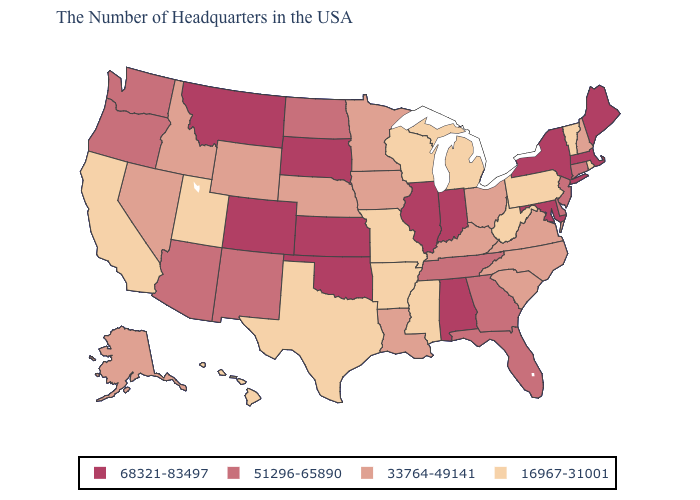Does the first symbol in the legend represent the smallest category?
Give a very brief answer. No. Which states have the highest value in the USA?
Be succinct. Maine, Massachusetts, New York, Maryland, Indiana, Alabama, Illinois, Kansas, Oklahoma, South Dakota, Colorado, Montana. What is the value of Nebraska?
Answer briefly. 33764-49141. What is the value of Arizona?
Answer briefly. 51296-65890. Name the states that have a value in the range 33764-49141?
Keep it brief. New Hampshire, Virginia, North Carolina, South Carolina, Ohio, Kentucky, Louisiana, Minnesota, Iowa, Nebraska, Wyoming, Idaho, Nevada, Alaska. How many symbols are there in the legend?
Write a very short answer. 4. Name the states that have a value in the range 51296-65890?
Give a very brief answer. Connecticut, New Jersey, Delaware, Florida, Georgia, Tennessee, North Dakota, New Mexico, Arizona, Washington, Oregon. Name the states that have a value in the range 68321-83497?
Concise answer only. Maine, Massachusetts, New York, Maryland, Indiana, Alabama, Illinois, Kansas, Oklahoma, South Dakota, Colorado, Montana. What is the lowest value in states that border Montana?
Answer briefly. 33764-49141. Among the states that border Wisconsin , does Michigan have the highest value?
Write a very short answer. No. Name the states that have a value in the range 33764-49141?
Concise answer only. New Hampshire, Virginia, North Carolina, South Carolina, Ohio, Kentucky, Louisiana, Minnesota, Iowa, Nebraska, Wyoming, Idaho, Nevada, Alaska. What is the value of Minnesota?
Give a very brief answer. 33764-49141. Among the states that border Kansas , which have the highest value?
Short answer required. Oklahoma, Colorado. Does the first symbol in the legend represent the smallest category?
Write a very short answer. No. What is the value of South Carolina?
Short answer required. 33764-49141. 